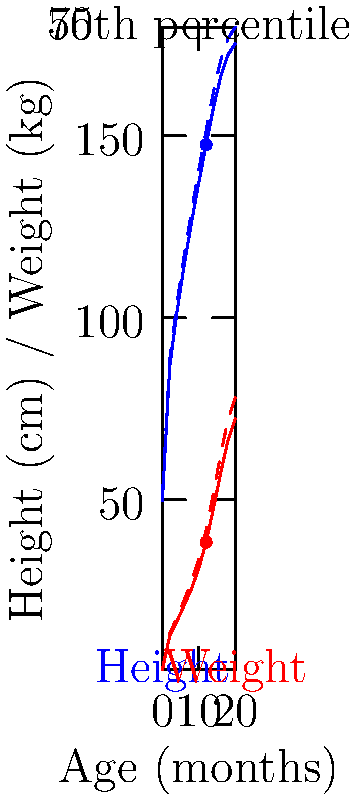A 12-month-old boy comes in for his well-child visit. His height is measured at 147.5 cm and his weight is 38.4 kg. Based on the growth chart provided, what can you conclude about this child's growth percentiles for height and weight? To interpret the growth chart and determine the child's percentiles, we need to follow these steps:

1. Locate the child's age (12 months) on the x-axis.
2. Find the corresponding height and weight measurements on the y-axis.
3. Compare these points to the percentile lines on the chart.

For height:
- The child's height (147.5 cm) at 12 months falls exactly on the blue solid line.
- The blue solid line represents the 50th percentile for height.
- Therefore, the child's height is at the 50th percentile.

For weight:
- The child's weight (38.4 kg) at 12 months falls exactly on the red solid line.
- The red solid line represents the 50th percentile for weight.
- Therefore, the child's weight is also at the 50th percentile.

Both measurements falling on the 50th percentile indicate that the child's growth is progressing typically, with both height and weight being average compared to other children of the same age and sex.

It's important to note that while single measurements are informative, tracking growth over time is more valuable for assessing a child's overall health and development.
Answer: Both height and weight are at the 50th percentile. 